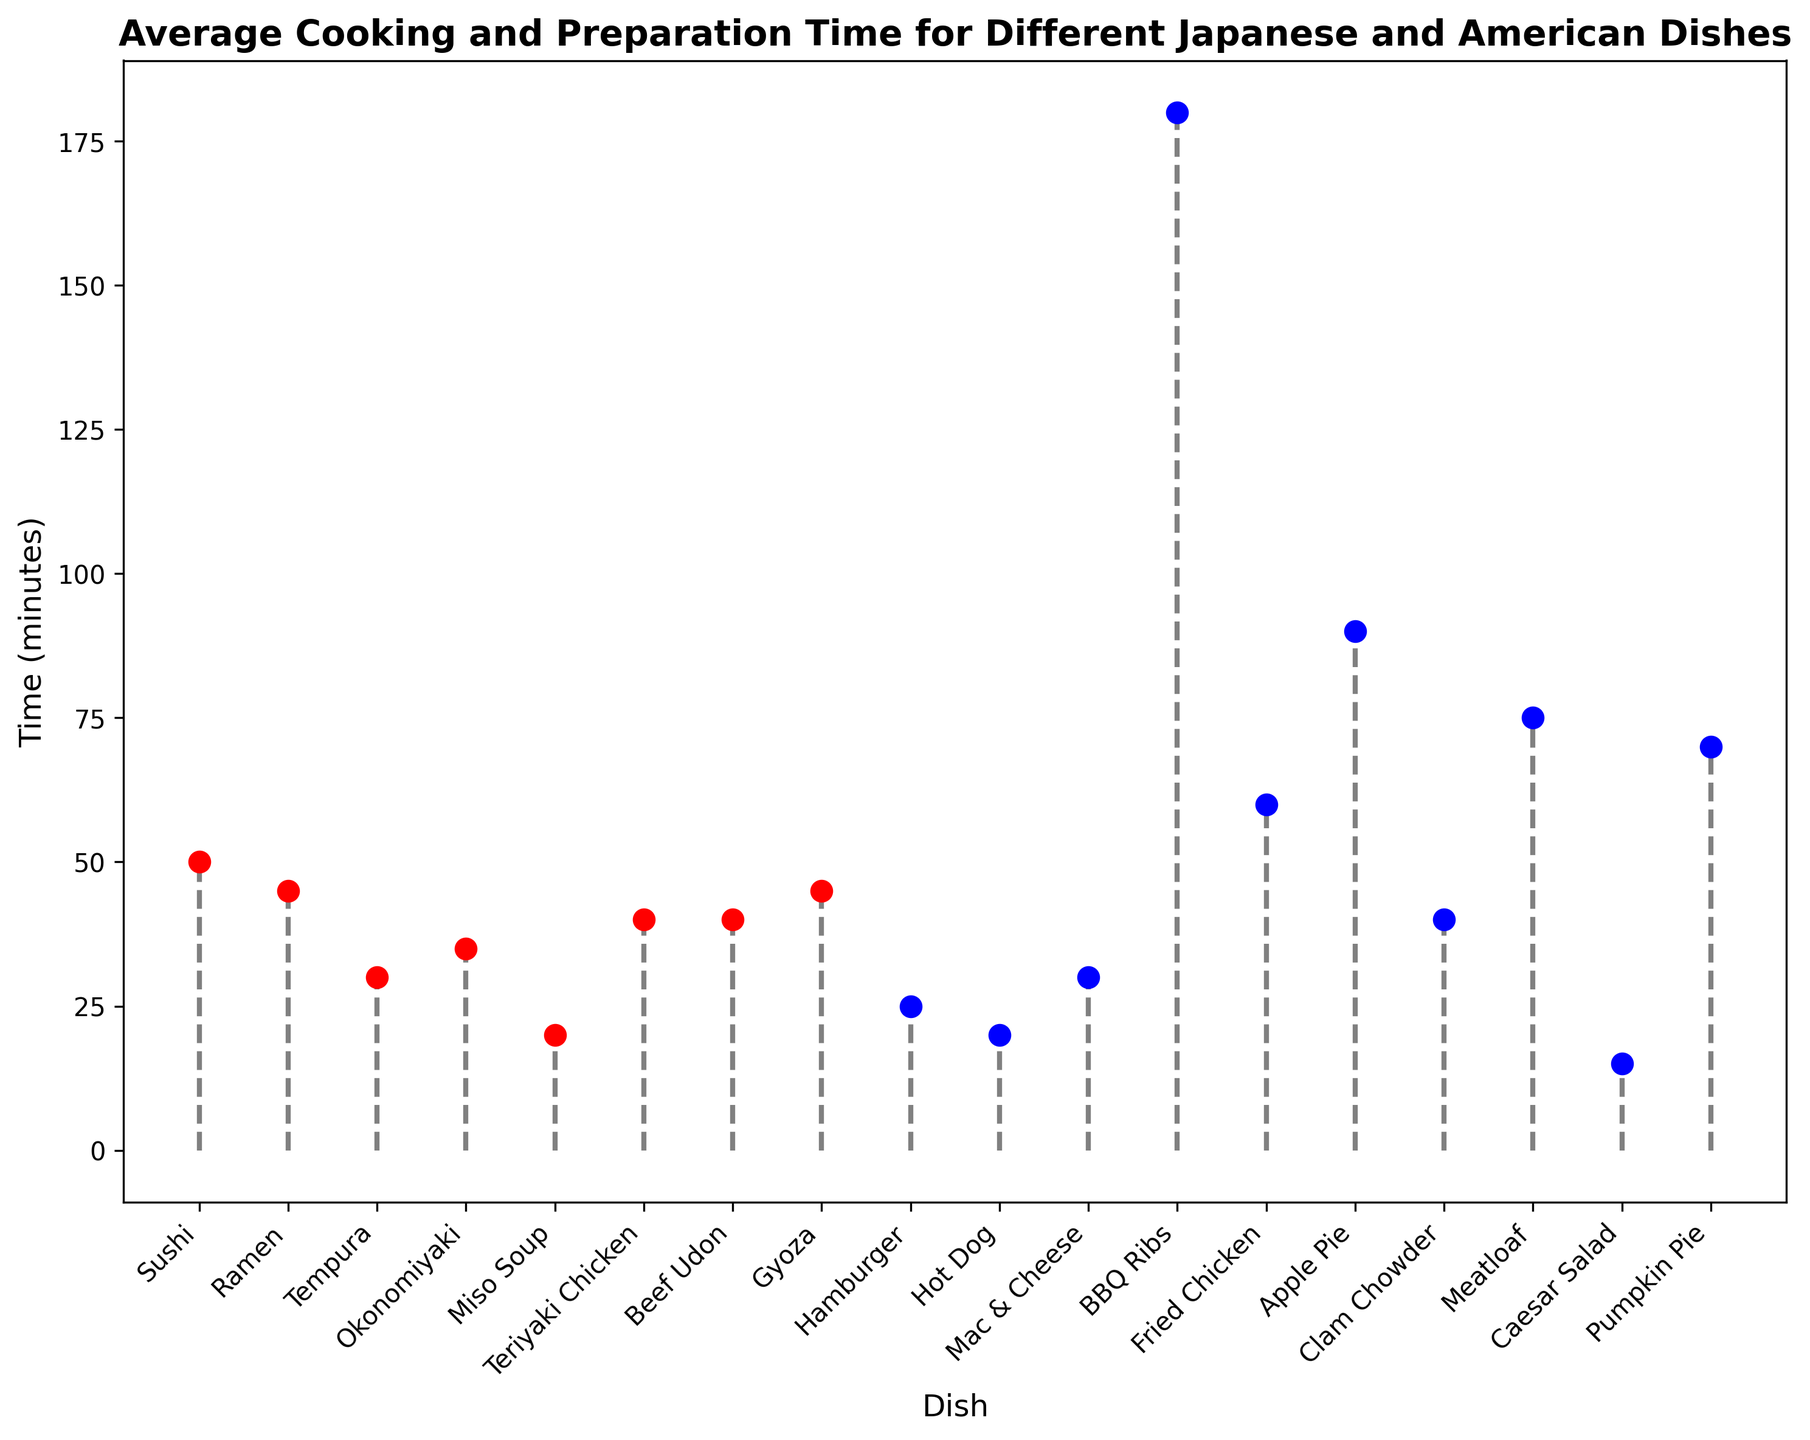Which dish takes the longest time to cook? By examining the height of the stems, we can see that BBQ Ribs have the highest stem, indicating the longest cooking time.
Answer: BBQ Ribs Which American dish takes the shortest time to cook? Observing the blue markers, the shortest stem is for Caesar Salad, indicating the least cooking/preparation time.
Answer: Caesar Salad How much longer does Apple Pie take to cook compared to Mac & Cheese? Find the heights of the stems for Apple Pie (90 minutes) and Mac & Cheese (30 minutes). Subtract the latter from the former: 90 - 30.
Answer: 60 minutes What is the average cooking time for the Japanese dishes listed? Sum the cooking times of all Japanese dishes: (50 + 45 + 30 + 35 + 20 + 40 + 40 + 45 = 305). Divide by the number of Japanese dishes (8). The average is 305 / 8.
Answer: 38.125 minutes Are there more Japanese or American dishes that take more than 40 minutes to cook? Count the number of dishes in each category with cooking times greater than 40 minutes. Japanese: 6 (Sushi, Ramen, Teriyaki Chicken, Beef Udon, Gyoza). American: 6 (BBQ Ribs, Fried Chicken, Apple Pie, Meatloaf, Pumpkin Pie). Both categories have the same number of dishes exceeding 40 minutes.
Answer: Same number Is there a dish type (Japanese or American) with a more consistent cooking time based on visual inspection? By observing the stems, Japanese dishes have shorter and more evenly distributed stems compared to American dishes, which have greater variability in stem heights, such as BBQ Ribs and Apple Pie.
Answer: Japanese dishes What is the total cooking time for all American dishes listed? Sum the cooking times for all American dishes: (25 + 20 + 30 + 180 + 60 + 90 + 40 + 75 + 15 + 70 = 605).
Answer: 605 minutes Which type of dishes (Japanese or American) has a dish with the shortest cooking time? Look for the shortest stem in the plot. The shortest stem belongs to Caesar Salad, an American dish.
Answer: American dishes Which Japanese dish takes the least time to cook? Identify the shortest stem among the red markers, which is Miso Soup.
Answer: Miso Soup Compare the cooking times of Sushi and Fried Chicken. How much longer does Fried Chicken take to cook than Sushi? Identify the stems for Sushi (50 minutes) and Fried Chicken (60 minutes). Subtract the cooking time for Sushi from that of Fried Chicken: 60 - 50.
Answer: 10 minutes 